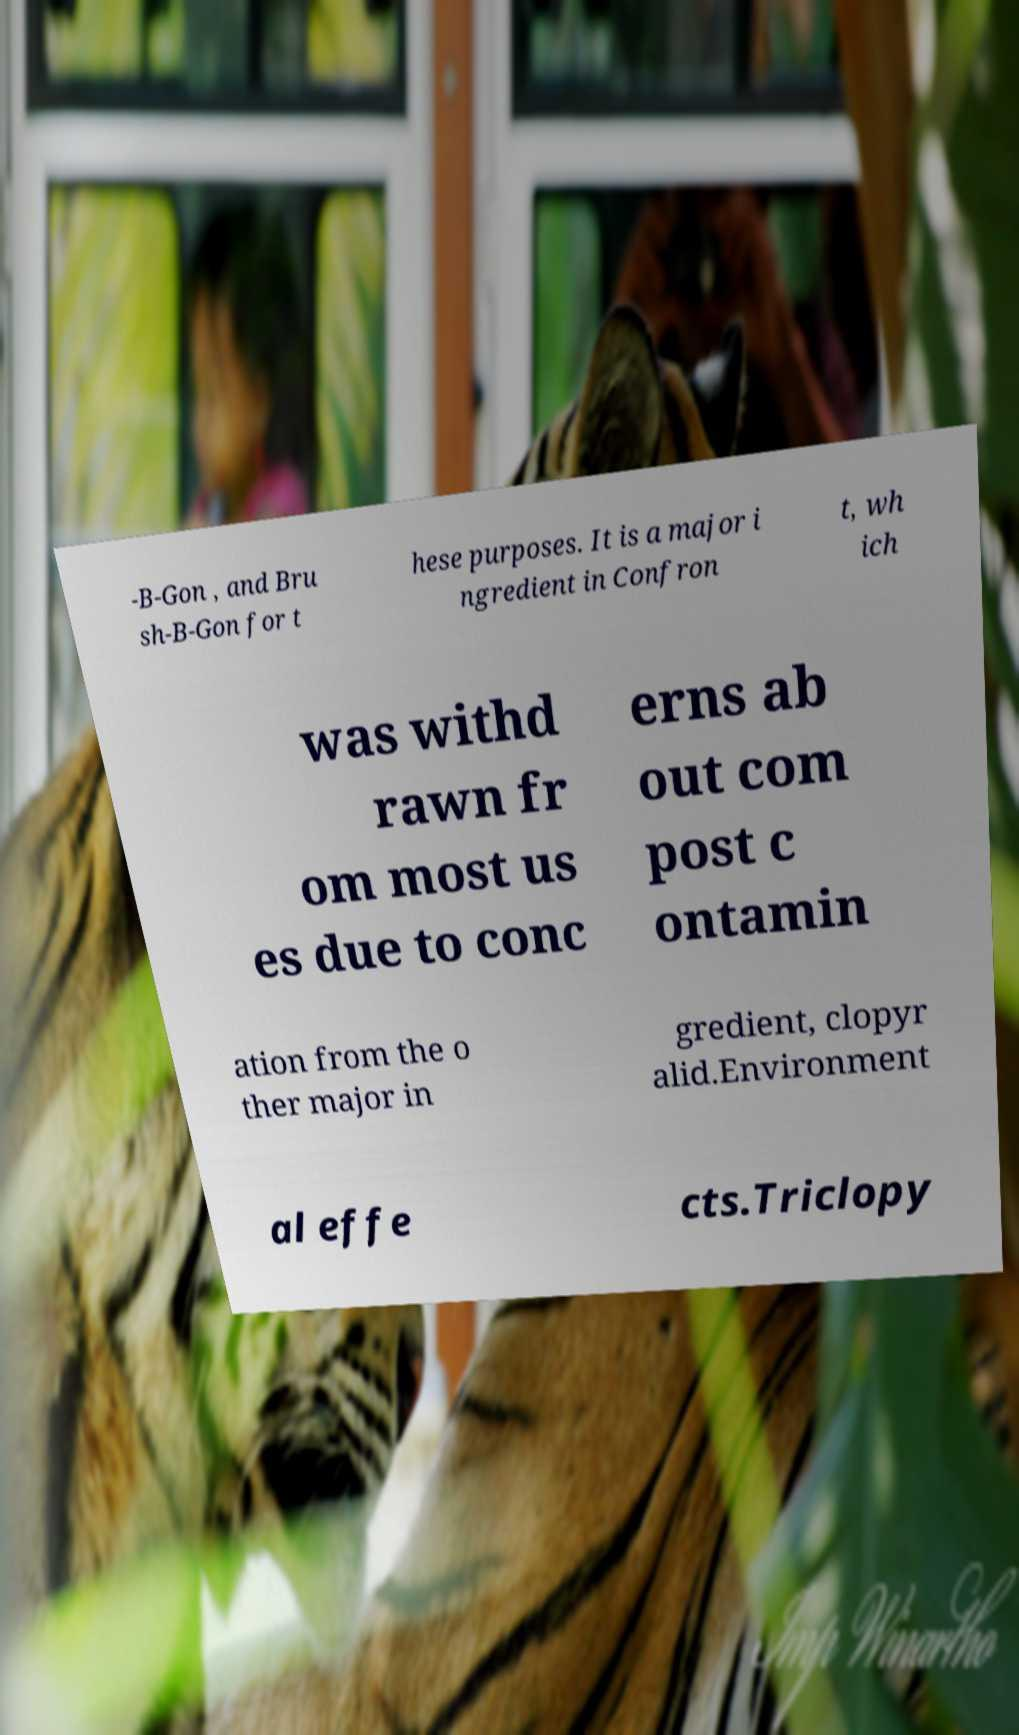Could you extract and type out the text from this image? -B-Gon , and Bru sh-B-Gon for t hese purposes. It is a major i ngredient in Confron t, wh ich was withd rawn fr om most us es due to conc erns ab out com post c ontamin ation from the o ther major in gredient, clopyr alid.Environment al effe cts.Triclopy 